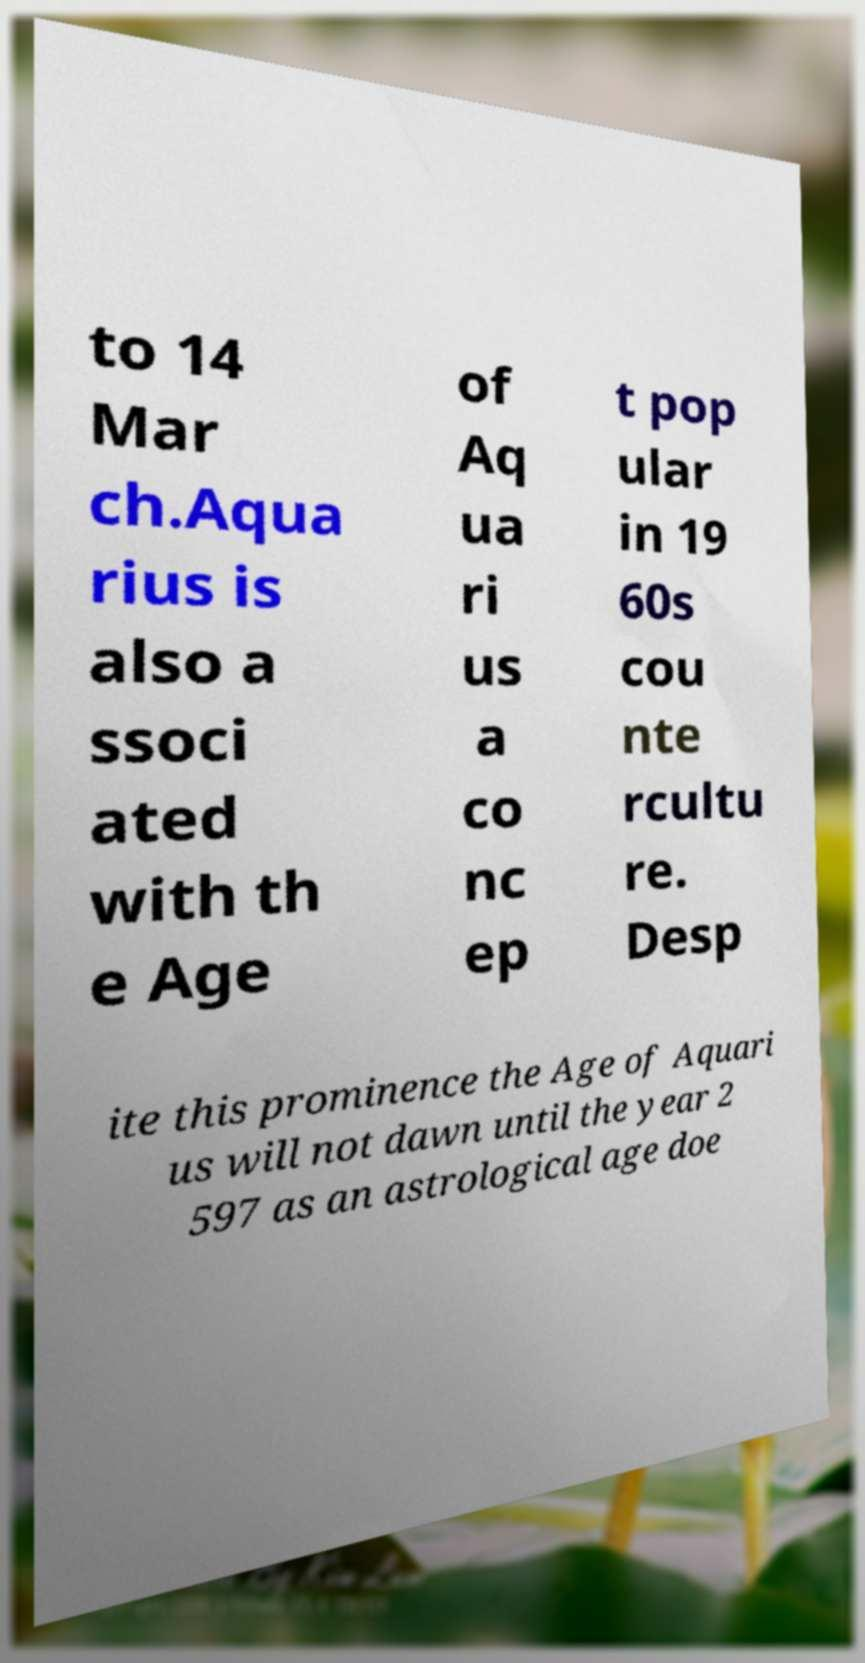Could you assist in decoding the text presented in this image and type it out clearly? to 14 Mar ch.Aqua rius is also a ssoci ated with th e Age of Aq ua ri us a co nc ep t pop ular in 19 60s cou nte rcultu re. Desp ite this prominence the Age of Aquari us will not dawn until the year 2 597 as an astrological age doe 